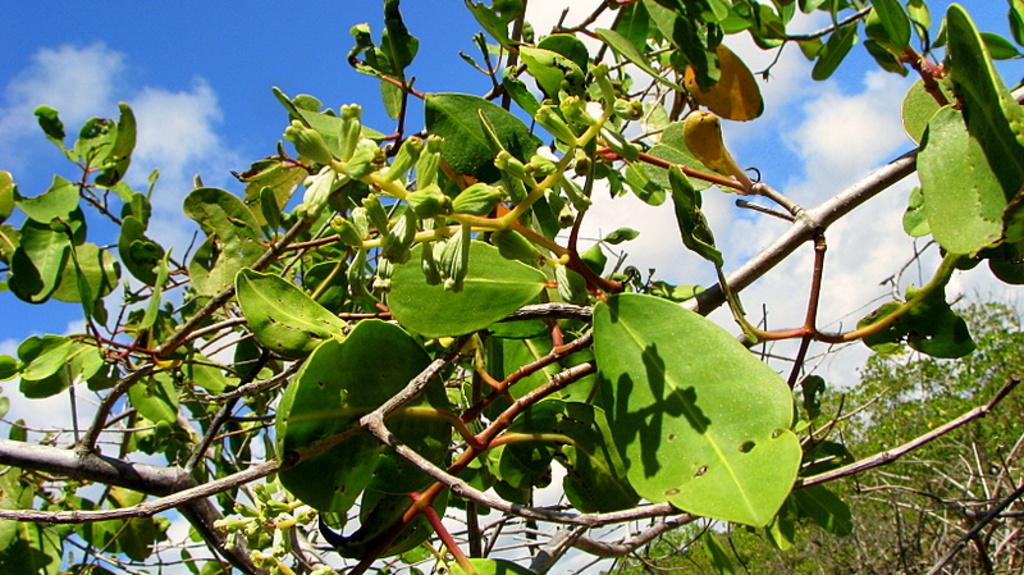What type of living organisms can be seen in the image? Plants can be seen in the image. What features do the plants have? The plants have leaves and flowers. What is visible in the background of the image? There is a tree and the sky visible in the background of the image. What can be seen in the sky? Clouds can be seen in the sky. What type of scarf is being worn by the tree in the image? There is no scarf present in the image, as the tree is a plant and not a person. 